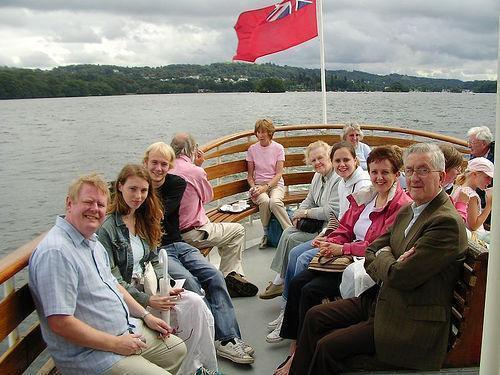What group of people are they likely to be?
Indicate the correct response and explain using: 'Answer: answer
Rationale: rationale.'
Options: Americans, russians, europeans, australians. Answer: europeans.
Rationale: I'm pretty sure that is the flag that represents great britain. therefore, these folks are most likely europeans. 